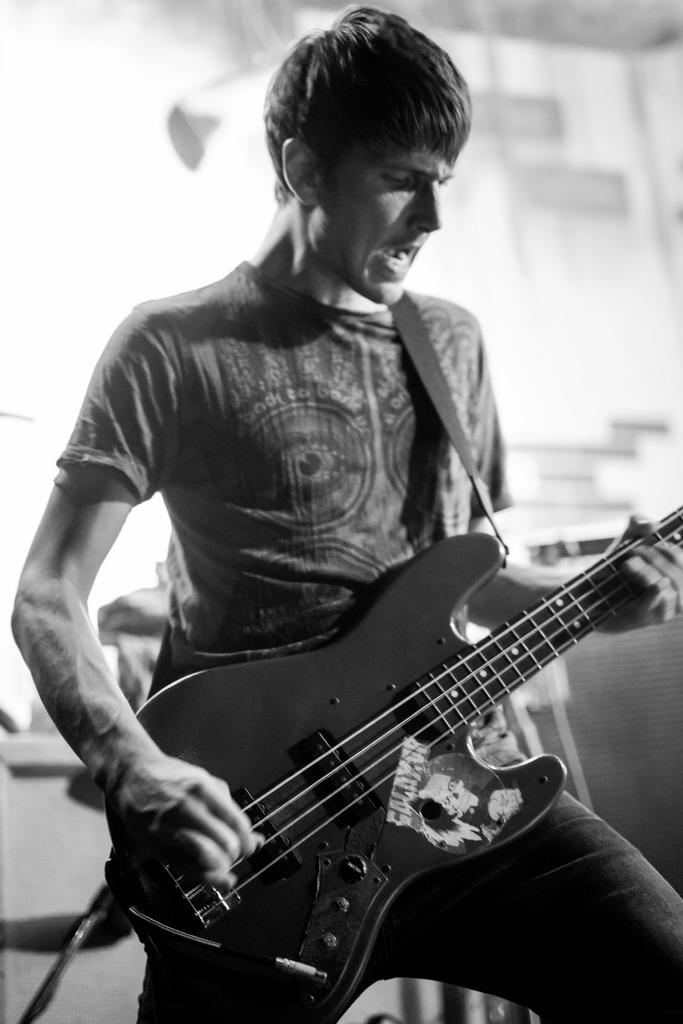Where was the image taken? The image was taken in a room. Who is present in the image? There is a man in the image. What is the man doing in the image? The man is standing and playing the guitar. What is the man holding in the image? The man is holding a guitar. What type of animal can be seen in the store in the image? There is no store or animal present in the image. The image is taken in a room and features a man playing a guitar. 